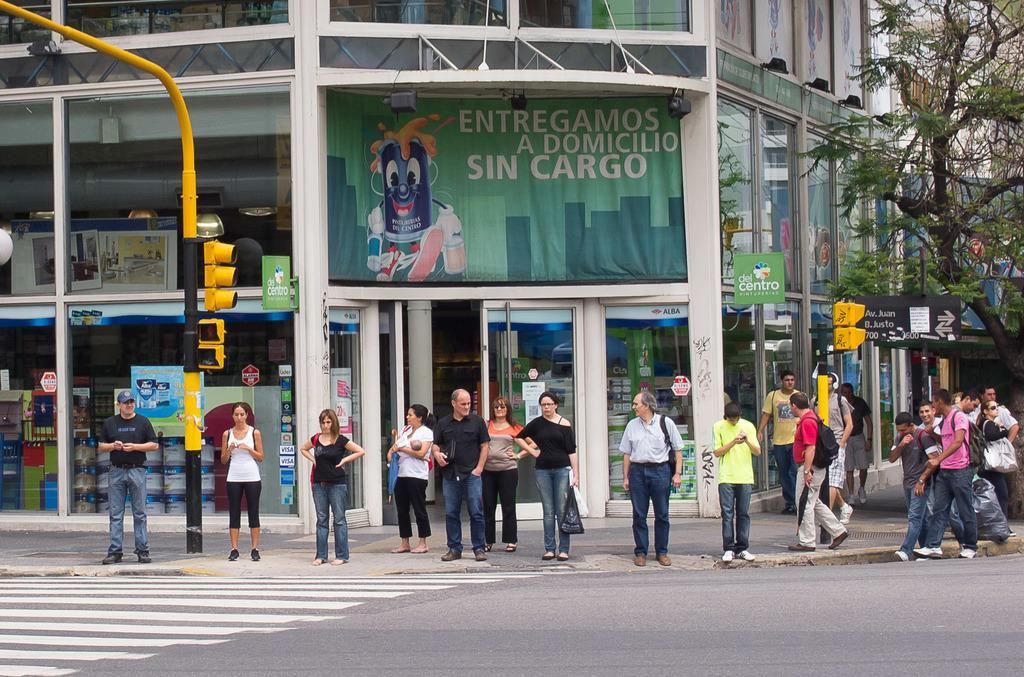How would you summarize this image in a sentence or two? In this image at front there is a road. Beside the road there is a traffic signal. At the back side there is a building. In front of the building people are standing on the pavement. At the right side of the image there is a tree. 